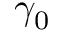<formula> <loc_0><loc_0><loc_500><loc_500>\gamma _ { 0 }</formula> 